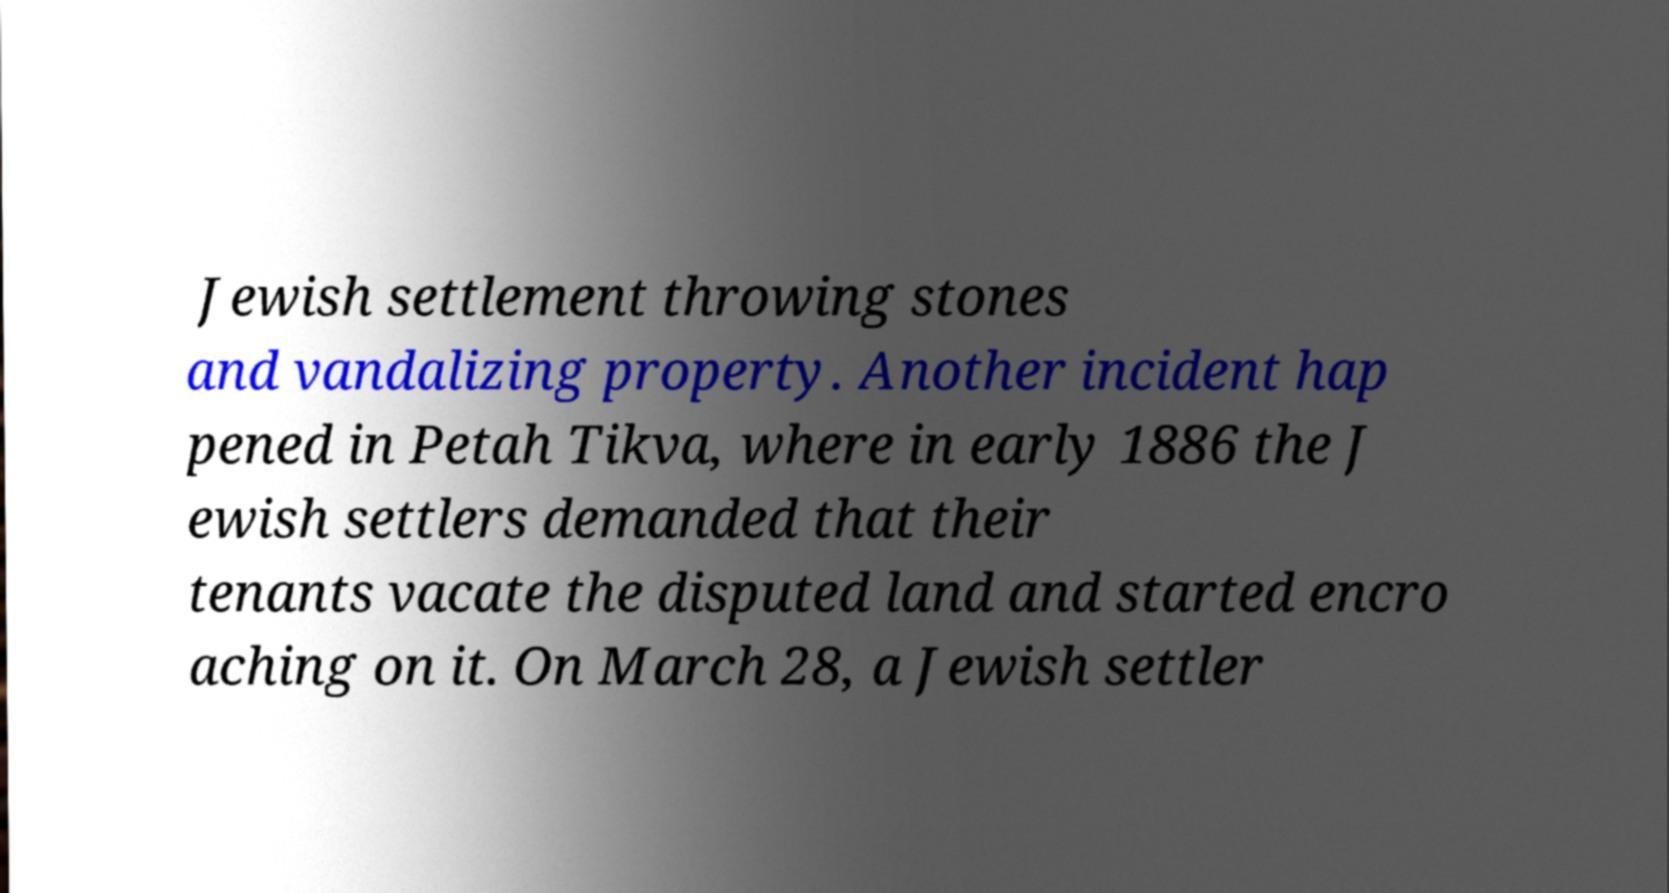I need the written content from this picture converted into text. Can you do that? Jewish settlement throwing stones and vandalizing property. Another incident hap pened in Petah Tikva, where in early 1886 the J ewish settlers demanded that their tenants vacate the disputed land and started encro aching on it. On March 28, a Jewish settler 